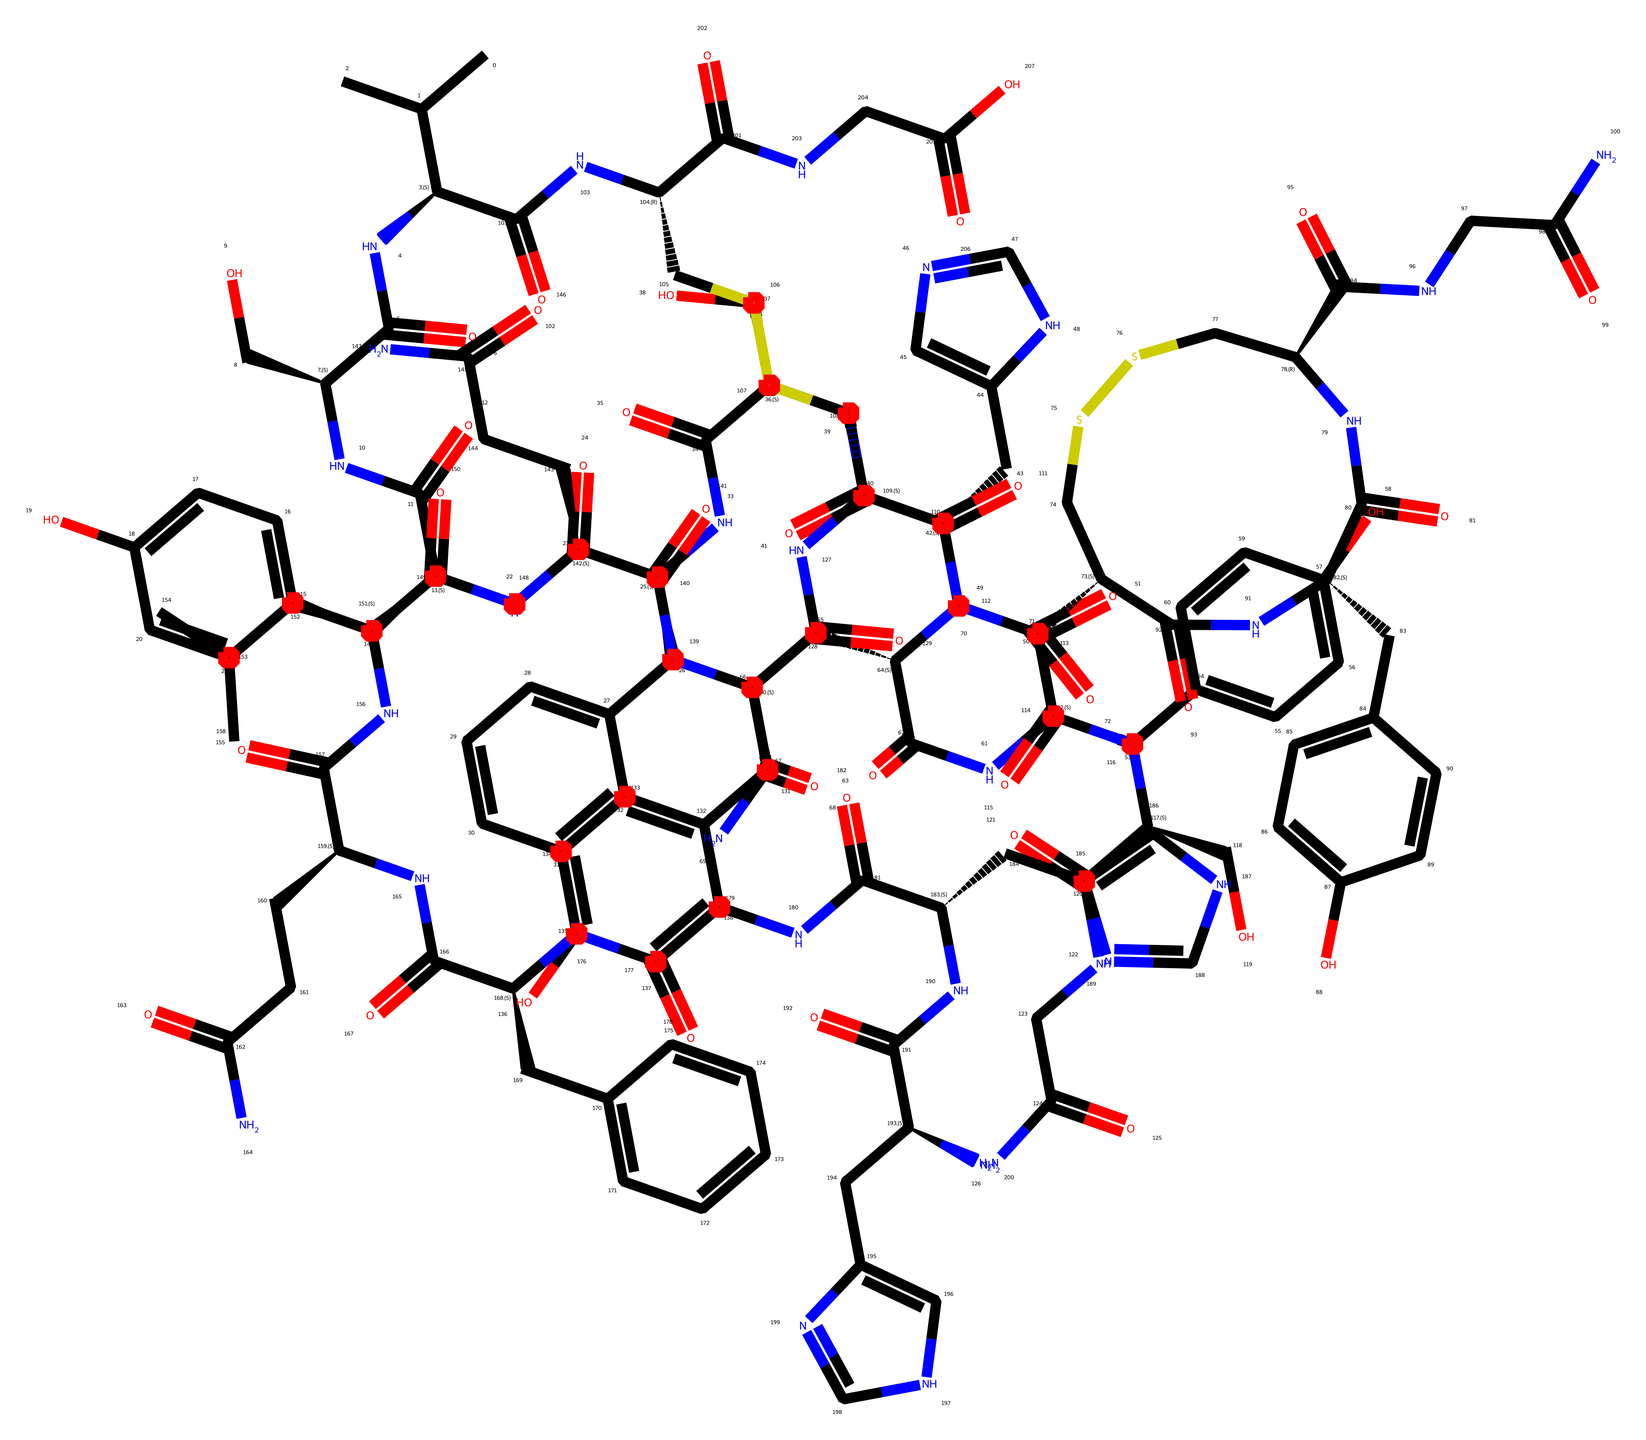What is the molecular formula of insulin based on its structural representation? The molecular formula is deduced by counting the number of carbon (C), hydrogen (H), nitrogen (N), oxygen (O), and sulfur (S) atoms present in the structure. By analyzing the SMILES notation, we find a total of 51 carbons, 75 hydrogens, 12 nitrogens, and 10 oxygens, leading to the molecular formula C51H75N12O10S.
Answer: C51H75N12O10S How many nitrogen atoms are present in insulin? The number of nitrogen atoms can be counted directly from the SMILES notation. In the representation, there are 12 occurrences of the nitrogen symbol (N). Thus, there are 12 nitrogen atoms in insulin.
Answer: 12 What is the significance of the sulfur atom in the insulin structure? The sulfur atom can be associated with the formation of disulfide bonds, which are crucial for the stability and structural integrity of the insulin molecule. By identifying the S atoms in the structure, we conclude the relevance of these interactions in the overall conformation of the hormone.
Answer: disulfide bonds Which functional groups are present in the insulin molecule? To determine the functional groups, we examine the structure for recognizable patterns such as amides (indicated by the presence of -NC(=O)- groups), alcohols (-OH groups), and carbonyls (C=O). By checking the SMILES notation, we find several amides due to the presence of multiple NC(=O) linkages, alcohol functionalities from -OH groups, and keto groups as well.
Answer: amides, alcohols, carbonyls What can be inferred about the polarity of insulin based on its structure? The polarity can be assessed by examining the functional groups and the overall distribution of polar atoms (like N and O) in the structure. The presence of multiple hydrophilic groups such as amides and alcohols suggests that insulin is polar, making it soluble in water, which is essential for its biological function.
Answer: polar How does the structure of insulin relate to its function in managing diabetes? The intricate structure, which includes various functional groups and disulfide bonds, is crucial for the hormone's ability to bind to insulin receptors effectively, regulate glucose uptake, and facilitate metabolism. The structure directly influences how insulin interacts with cells, thus impacting its role in blood sugar management.
Answer: binding effectiveness What role do the cyclic structures play in insulin’s overall configuration? Cyclic structures often contribute to the 3D conformation of the molecule, affecting its stability and biological activity. The presence of aromatic rings in the insulin structure can contribute to the rigidity and the ability to interact with specific receptors at a molecular level.
Answer: stability and interaction 